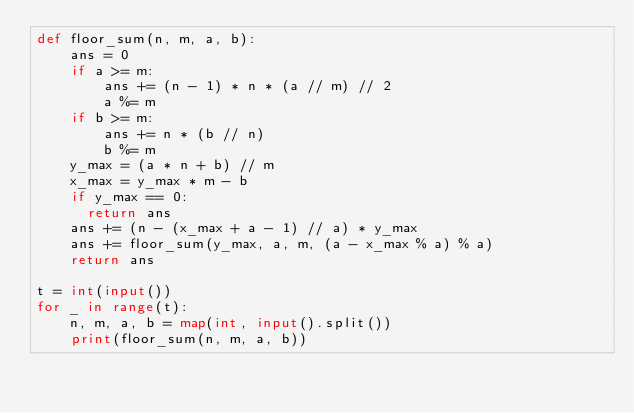<code> <loc_0><loc_0><loc_500><loc_500><_Python_>def floor_sum(n, m, a, b):
    ans = 0
    if a >= m:
        ans += (n - 1) * n * (a // m) // 2
        a %= m
    if b >= m:
        ans += n * (b // n)
        b %= m
    y_max = (a * n + b) // m
    x_max = y_max * m - b
    if y_max == 0:
      return ans
    ans += (n - (x_max + a - 1) // a) * y_max
    ans += floor_sum(y_max, a, m, (a - x_max % a) % a)
    return ans

t = int(input())
for _ in range(t):
    n, m, a, b = map(int, input().split())
    print(floor_sum(n, m, a, b))
</code> 